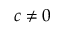Convert formula to latex. <formula><loc_0><loc_0><loc_500><loc_500>c \neq 0</formula> 